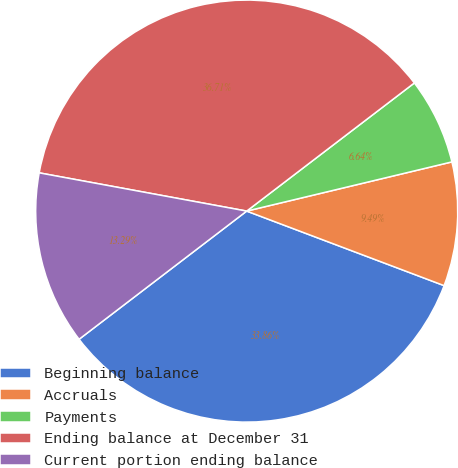Convert chart. <chart><loc_0><loc_0><loc_500><loc_500><pie_chart><fcel>Beginning balance<fcel>Accruals<fcel>Payments<fcel>Ending balance at December 31<fcel>Current portion ending balance<nl><fcel>33.86%<fcel>9.49%<fcel>6.64%<fcel>36.71%<fcel>13.29%<nl></chart> 